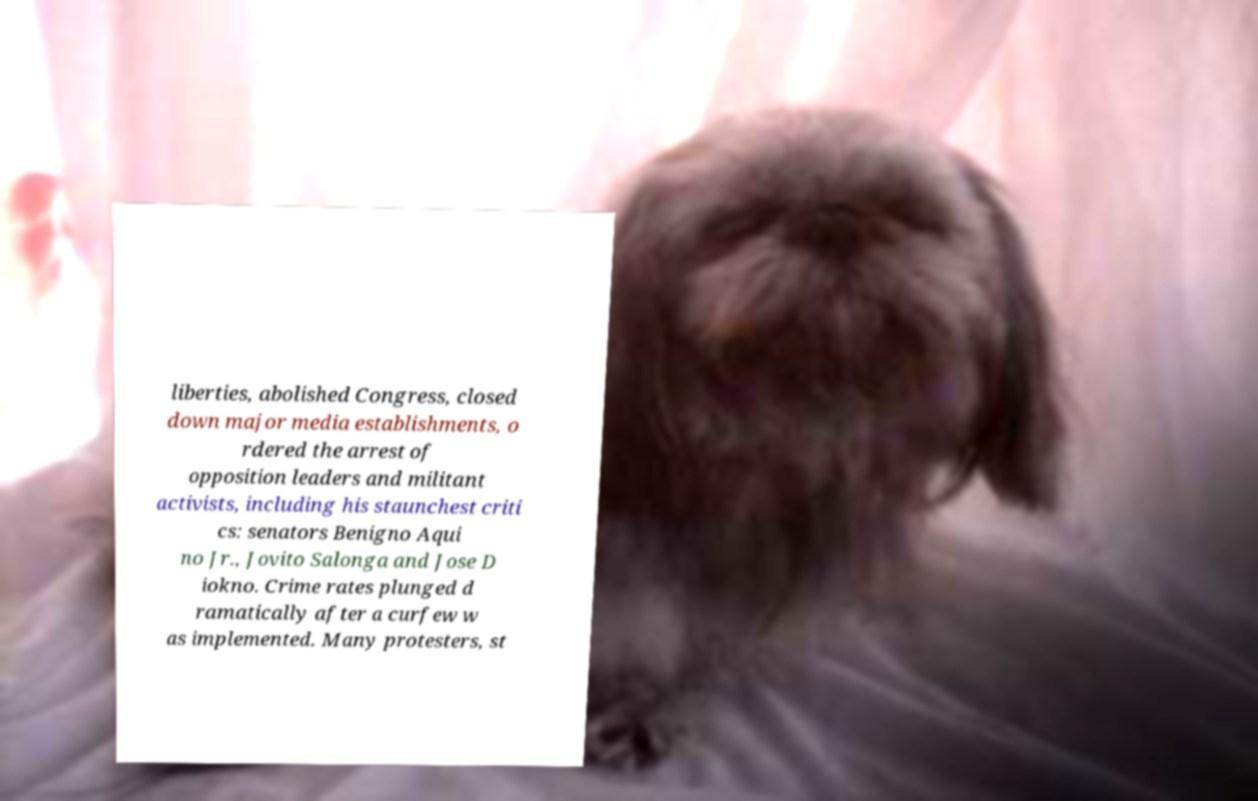Could you assist in decoding the text presented in this image and type it out clearly? liberties, abolished Congress, closed down major media establishments, o rdered the arrest of opposition leaders and militant activists, including his staunchest criti cs: senators Benigno Aqui no Jr., Jovito Salonga and Jose D iokno. Crime rates plunged d ramatically after a curfew w as implemented. Many protesters, st 